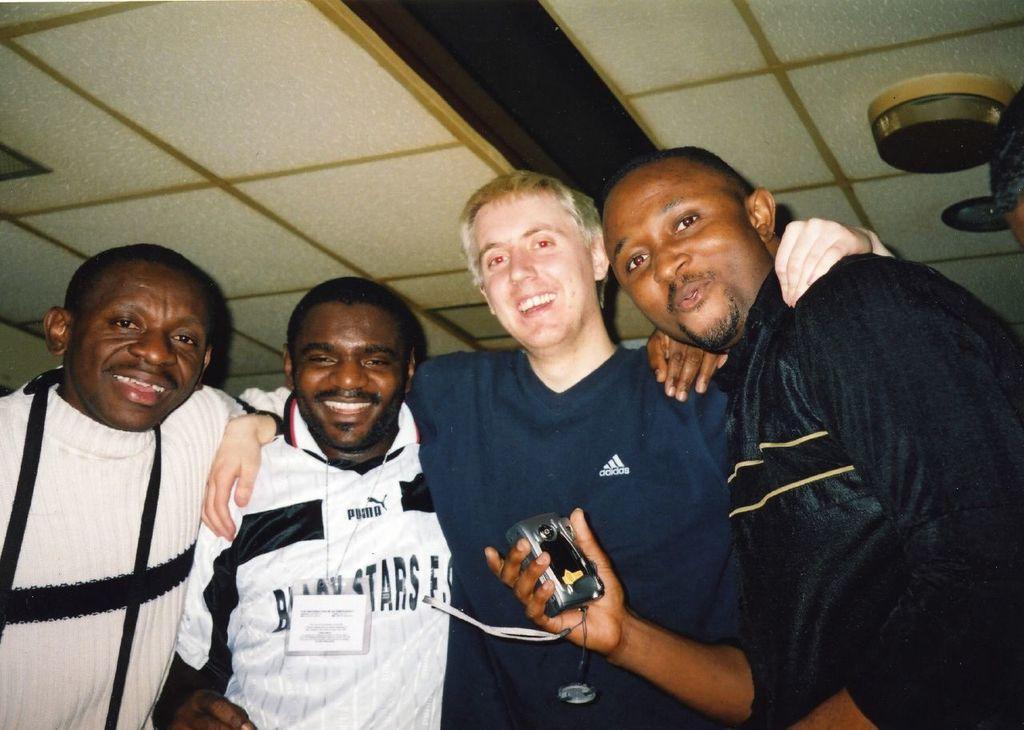How would you summarize this image in a sentence or two? This picture shows few people standing with smile on their faces and we see a man holding a camera in his hand and another man wore ID card. 